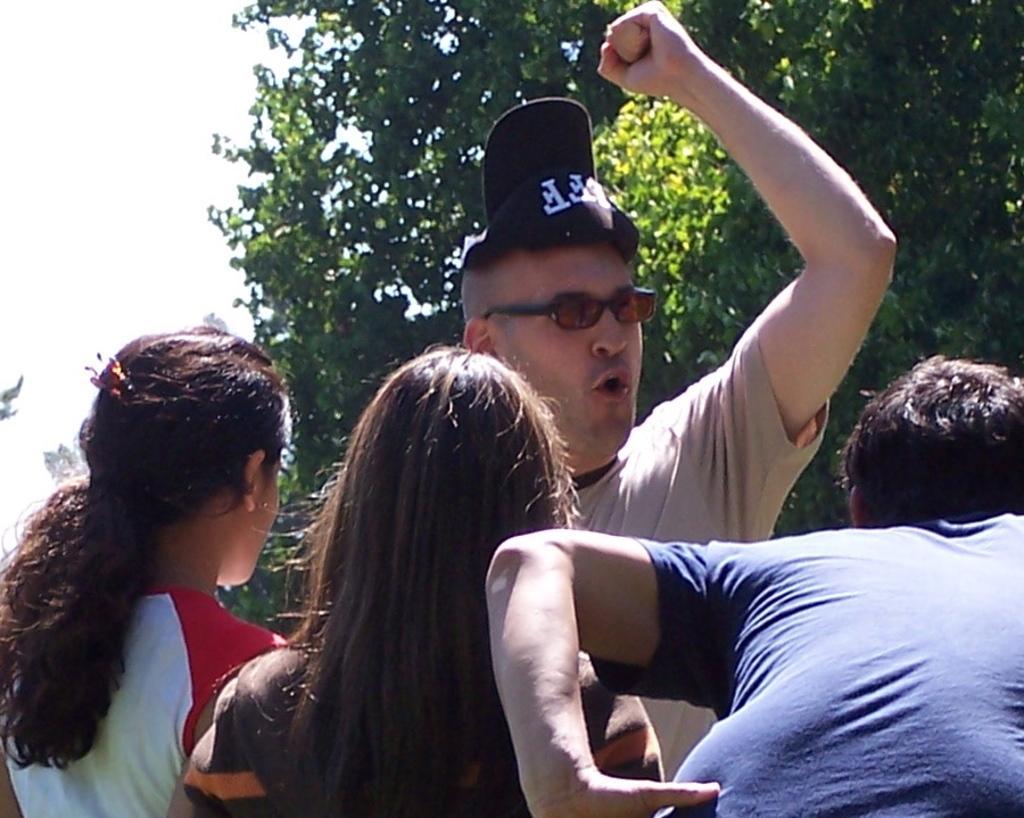Describe this image in one or two sentences. In the center of the image there are group of persons standing. In the background there is a tree and sky. 